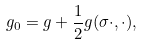<formula> <loc_0><loc_0><loc_500><loc_500>g _ { 0 } = g + \frac { 1 } { 2 } g ( \sigma \cdot , \cdot ) ,</formula> 